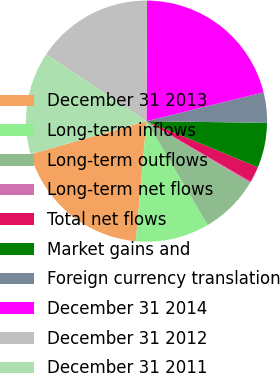Convert chart to OTSL. <chart><loc_0><loc_0><loc_500><loc_500><pie_chart><fcel>December 31 2013<fcel>Long-term inflows<fcel>Long-term outflows<fcel>Long-term net flows<fcel>Total net flows<fcel>Market gains and<fcel>Foreign currency translation<fcel>December 31 2014<fcel>December 31 2012<fcel>December 31 2011<nl><fcel>19.15%<fcel>9.9%<fcel>7.96%<fcel>0.18%<fcel>2.13%<fcel>6.02%<fcel>4.07%<fcel>21.09%<fcel>15.72%<fcel>13.78%<nl></chart> 